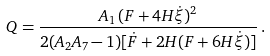Convert formula to latex. <formula><loc_0><loc_0><loc_500><loc_500>Q = \frac { A _ { 1 } \, ( F + 4 H \dot { \xi } ) ^ { 2 } } { 2 ( A _ { 2 } A _ { 7 } - 1 ) [ \dot { F } + 2 H ( F + 6 H \dot { \xi } ) ] } \, .</formula> 